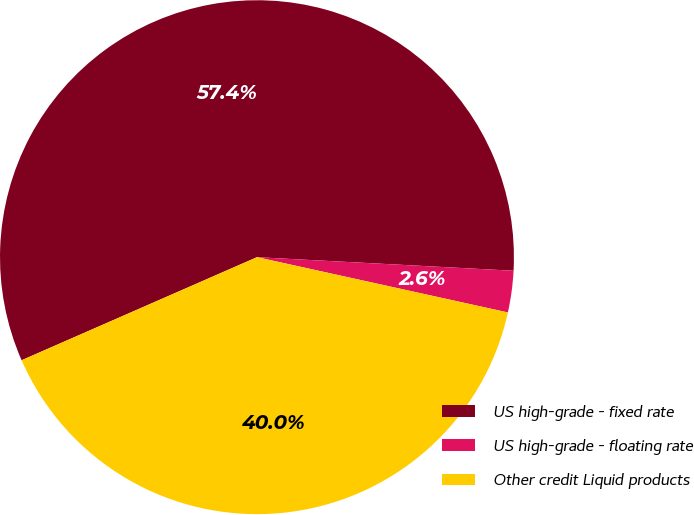Convert chart. <chart><loc_0><loc_0><loc_500><loc_500><pie_chart><fcel>US high-grade - fixed rate<fcel>US high-grade - floating rate<fcel>Other credit Liquid products<nl><fcel>57.41%<fcel>2.61%<fcel>39.98%<nl></chart> 